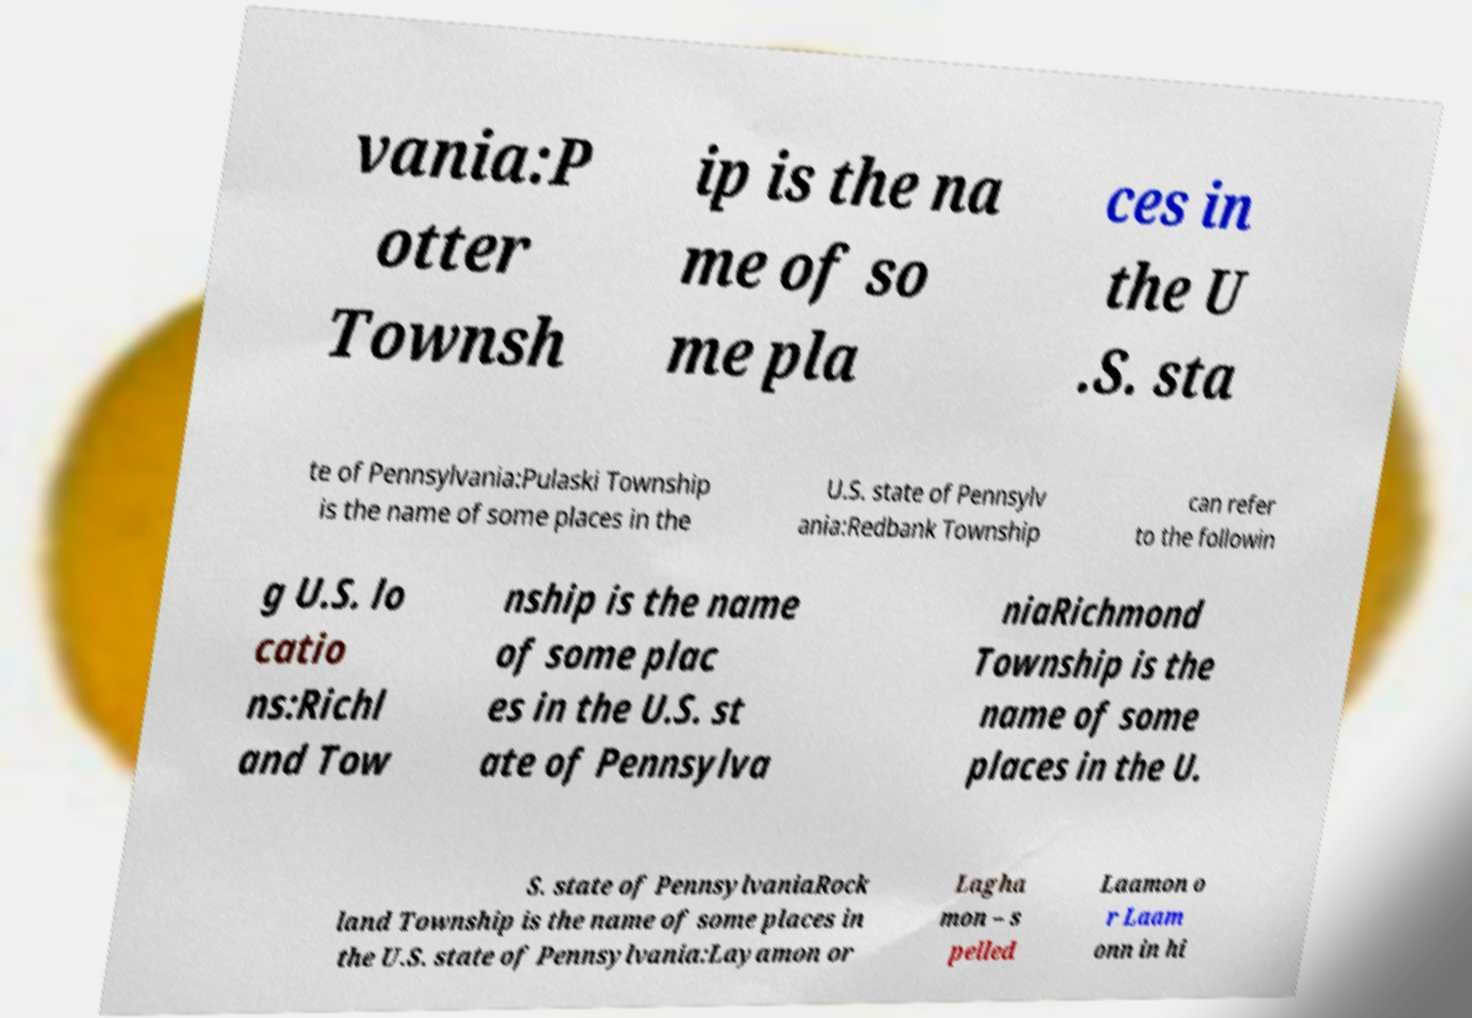For documentation purposes, I need the text within this image transcribed. Could you provide that? vania:P otter Townsh ip is the na me of so me pla ces in the U .S. sta te of Pennsylvania:Pulaski Township is the name of some places in the U.S. state of Pennsylv ania:Redbank Township can refer to the followin g U.S. lo catio ns:Richl and Tow nship is the name of some plac es in the U.S. st ate of Pennsylva niaRichmond Township is the name of some places in the U. S. state of PennsylvaniaRock land Township is the name of some places in the U.S. state of Pennsylvania:Layamon or Lagha mon – s pelled Laamon o r Laam onn in hi 